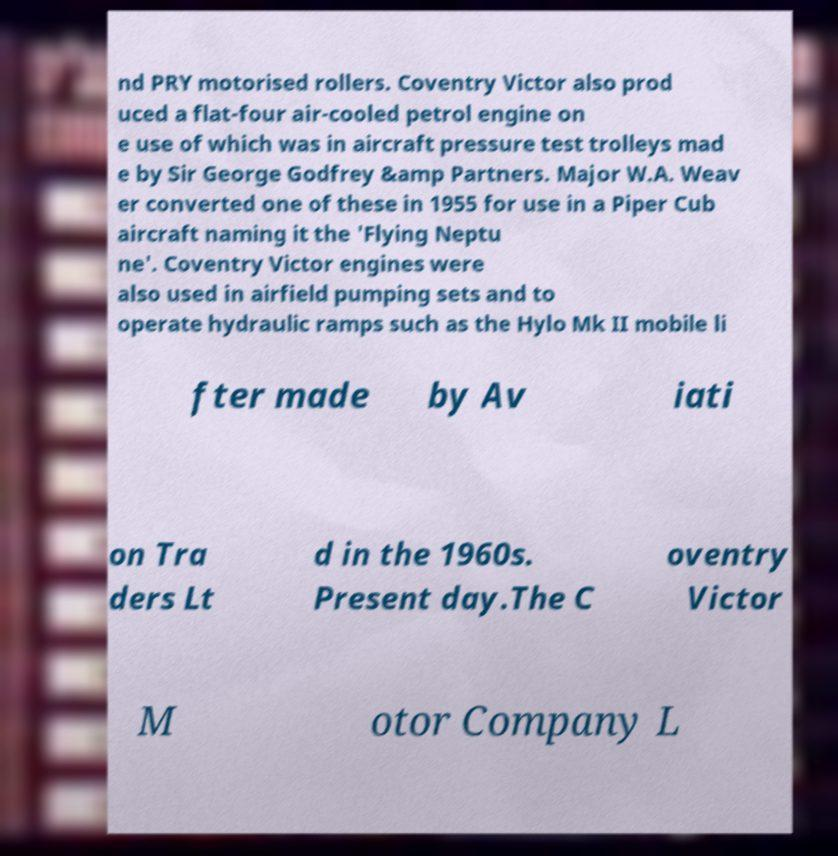Could you extract and type out the text from this image? nd PRY motorised rollers. Coventry Victor also prod uced a flat-four air-cooled petrol engine on e use of which was in aircraft pressure test trolleys mad e by Sir George Godfrey &amp Partners. Major W.A. Weav er converted one of these in 1955 for use in a Piper Cub aircraft naming it the 'Flying Neptu ne'. Coventry Victor engines were also used in airfield pumping sets and to operate hydraulic ramps such as the Hylo Mk II mobile li fter made by Av iati on Tra ders Lt d in the 1960s. Present day.The C oventry Victor M otor Company L 